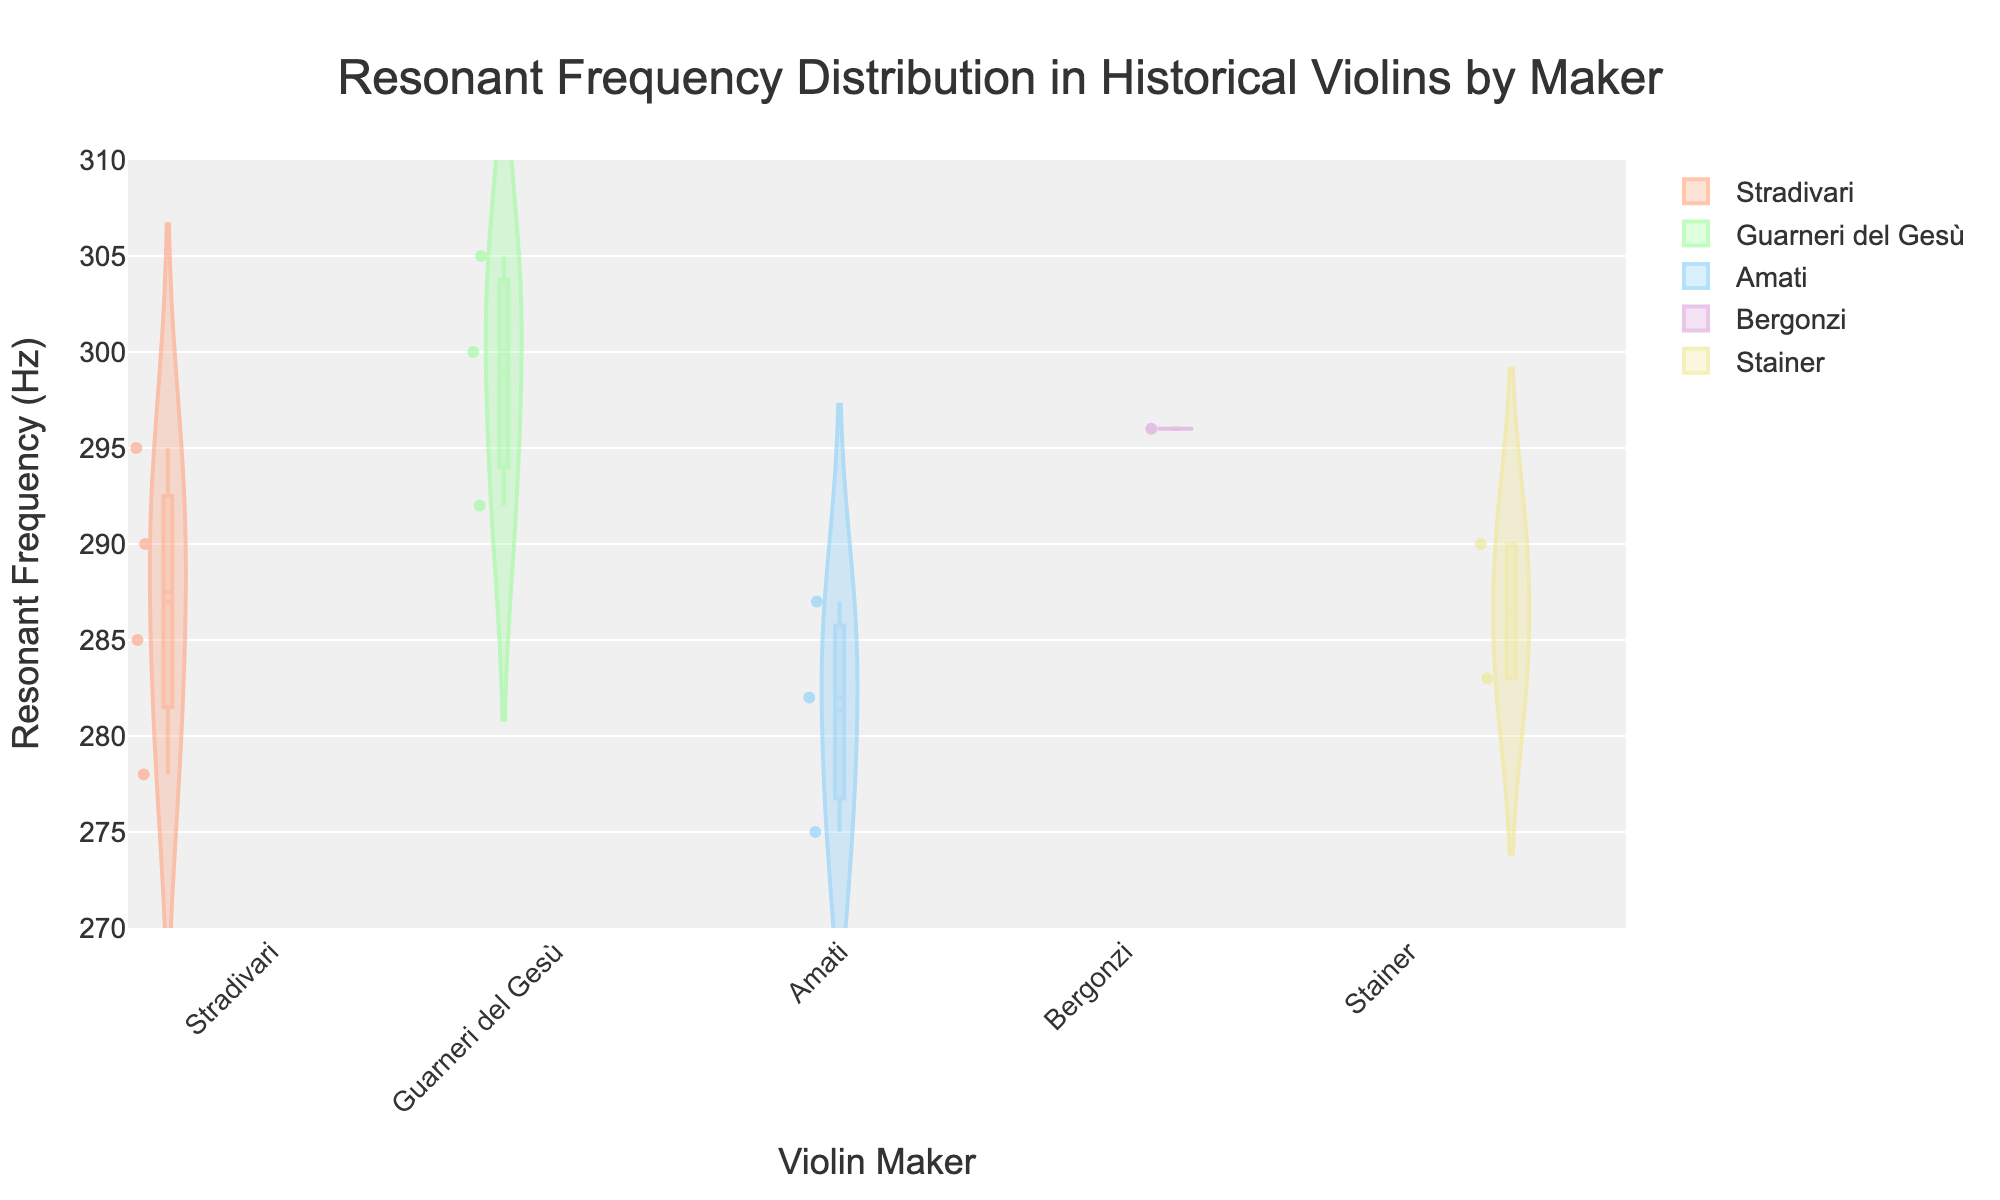What is the title of the figure? The title of a figure is typically placed at the top and is intended to give an immediate idea of what the figure is about. Here, the title reads "Resonant Frequency Distribution in Historical Violins by Maker".
Answer: Resonant Frequency Distribution in Historical Violins by Maker Which violin maker has the widest range of resonant frequencies in this figure? Look for the maker with the broadest spread in their violin plot. Guarneri del Gesù's violins, for example, cover a wide range from around 290 Hz to 305 Hz.
Answer: Guarneri del Gesù What is the median resonant frequency of Stradivari violins? The median is indicated by the central line in the box plot overlay. For Stradivari, this line is at approximately 285 Hz.
Answer: 285 Hz Which violin maker has the highest maximum resonant frequency and what is it? Check the topmost point of each violin plot. Guarneri del Gesù has the highest maximum resonant frequency at around 305 Hz.
Answer: Guarneri del Gesù, 305 Hz How does the mean resonant frequency of Stainer violins compare to that of Gagliano violins? The mean is indicated by a horizontal line within each violin plot. For Stainer, the mean is around 287 Hz, while for Gagliano, it is approximately 282.5 Hz. Hence, Stainer's mean is higher.
Answer: Stainer’s mean is higher Which violin maker shows the smallest interquartile range (IQR) for resonant frequencies? The IQR is the range between the lower and upper quartiles on the box plot. Stainer shows the smallest IQR as their box plot is the narrowest.
Answer: Stainer What is the average resonant frequency of Amati violins? The average can be calculated by summing all resonant frequencies of Amati violins and dividing by the count. (275 + 282 + 287) / 3 = 844 / 3 ≈ 281.33 Hz.
Answer: 281.33 Hz Do any violin makers have an outlier in their resonant frequencies? Outliers in box plots are generally shown as individual points outside the whiskers. There are no individual points significantly separated from the rest, indicating no outliers.
Answer: No Which violin maker exhibits the narrowest distribution in their resonant frequencies? The narrowest distribution is indicated by the shortest and least spread violin plot in terms of both the violin shape and box plot width. Stainer and Gagliano both seem to have relatively narrow distributions, but Stainer is the narrowest.
Answer: Stainer Between Amati and Stradivari, who has the higher maximum resonant frequency? The maximum resonant frequency for Amati is around 287 Hz while for Stradivari it is around 295 Hz. Hence, Stradivari has the higher maximum resonant frequency.
Answer: Stradivari 